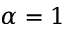<formula> <loc_0><loc_0><loc_500><loc_500>\alpha = 1</formula> 